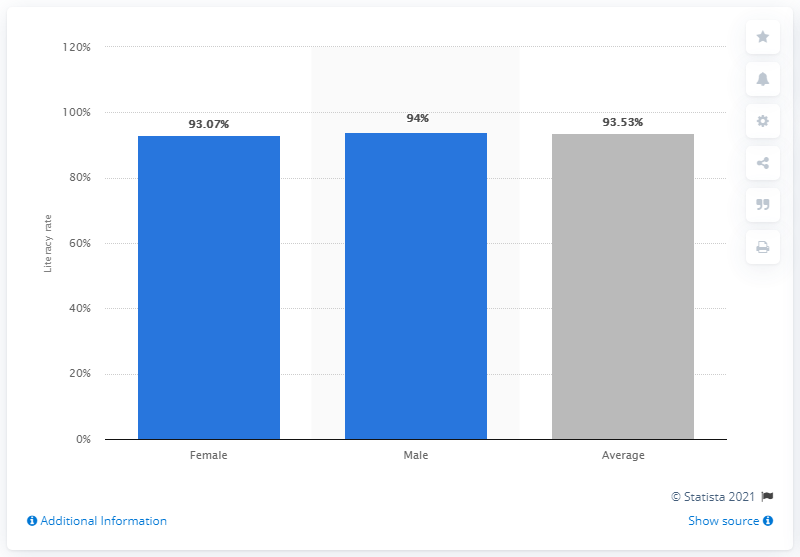Give some essential details in this illustration. In 2016, the literacy rate among women in Latin America and the Caribbean was 93.53%. 